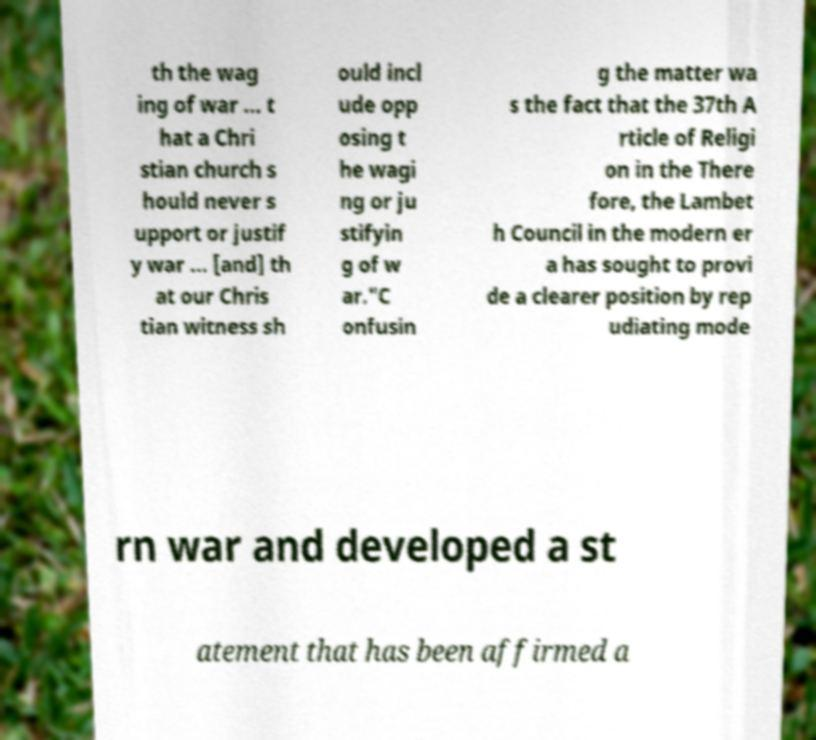Can you read and provide the text displayed in the image?This photo seems to have some interesting text. Can you extract and type it out for me? th the wag ing of war ... t hat a Chri stian church s hould never s upport or justif y war ... [and] th at our Chris tian witness sh ould incl ude opp osing t he wagi ng or ju stifyin g of w ar."C onfusin g the matter wa s the fact that the 37th A rticle of Religi on in the There fore, the Lambet h Council in the modern er a has sought to provi de a clearer position by rep udiating mode rn war and developed a st atement that has been affirmed a 